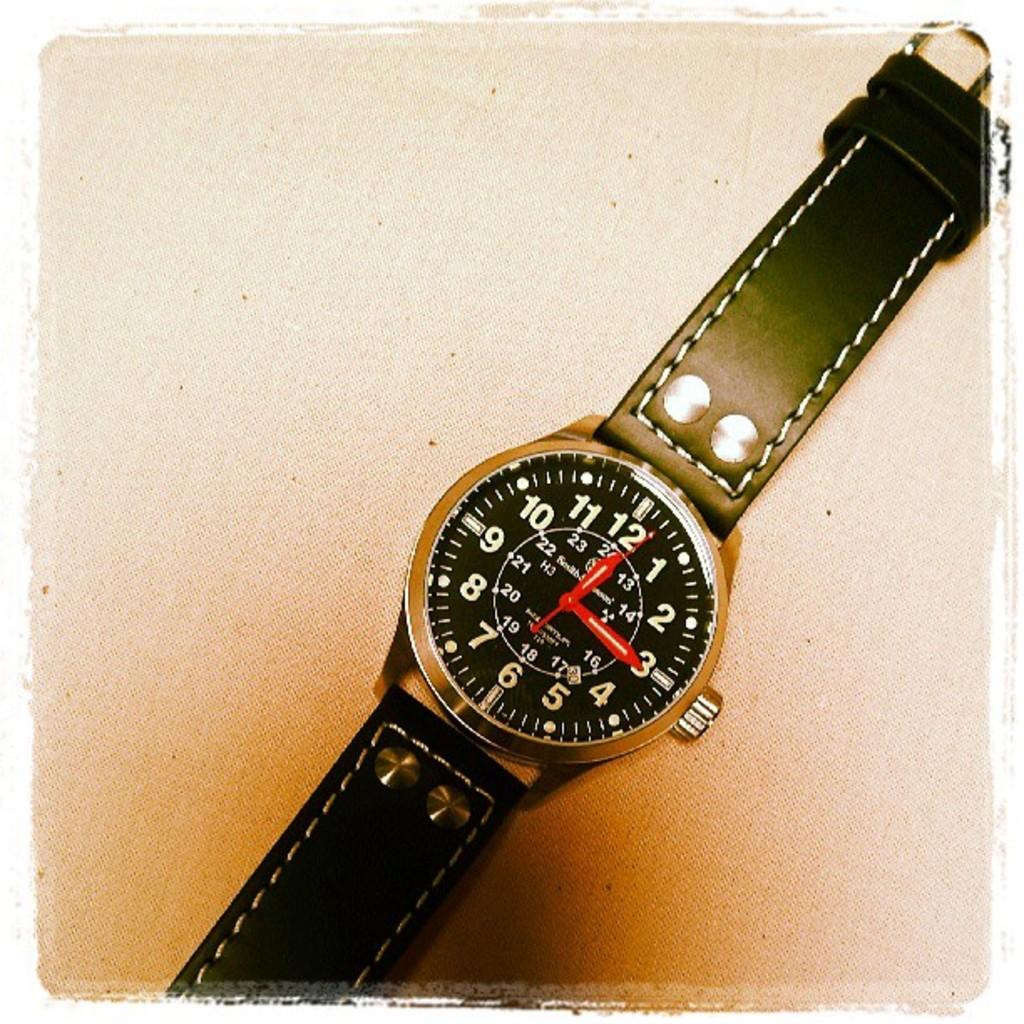What time is shown?
Give a very brief answer. 12:15. What is a time not shown?
Your answer should be compact. Answering does not require reading text in the image. 